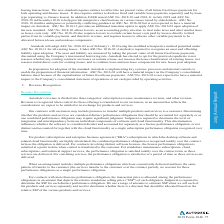According to Autodesk's financial document, Where are the short term and long term "contract assets" under ASC Topic 606? Based on the financial document, the answer is within "Prepaid expenses and other current assets" and "Other assets", respectively,. Also, What is the impact the standard on net cash provided in financing? Based on the financial document, the answer is no impact. Also, What is the net adjusted accounts receivable? Based on the financial document, the answer is $547.7 (in millions). Also, can you calculate: What would be the accumulated deficit adjustment without the  $179.4 million adjustment for adopting ASC Topic 606 and 340-40 on the opening balance as of February 1, 2018? Based on the calculation: 189.5-179.4, the result is 10.1 (in millions). The key data points involved are: 179.4, 189.5. Also, can you calculate: What is the reported current ratio?  To answer this question, I need to perform calculations using the financial data. The calculation is: (474.3+192.1+65.3+337.8)/(1,763.3+142.3+328.1+21.5+79.8), which equals 0.46. The key data points involved are: 1,763.3, 142.3, 192.1. Also, can you calculate: How much did the deferred revenue change due to the adoption of ASC 606 and 340-40? Based on the calculation: 140.6/1,763.3 , the result is 7.97 (percentage). The key data points involved are: 1,763.3, 140.6. 